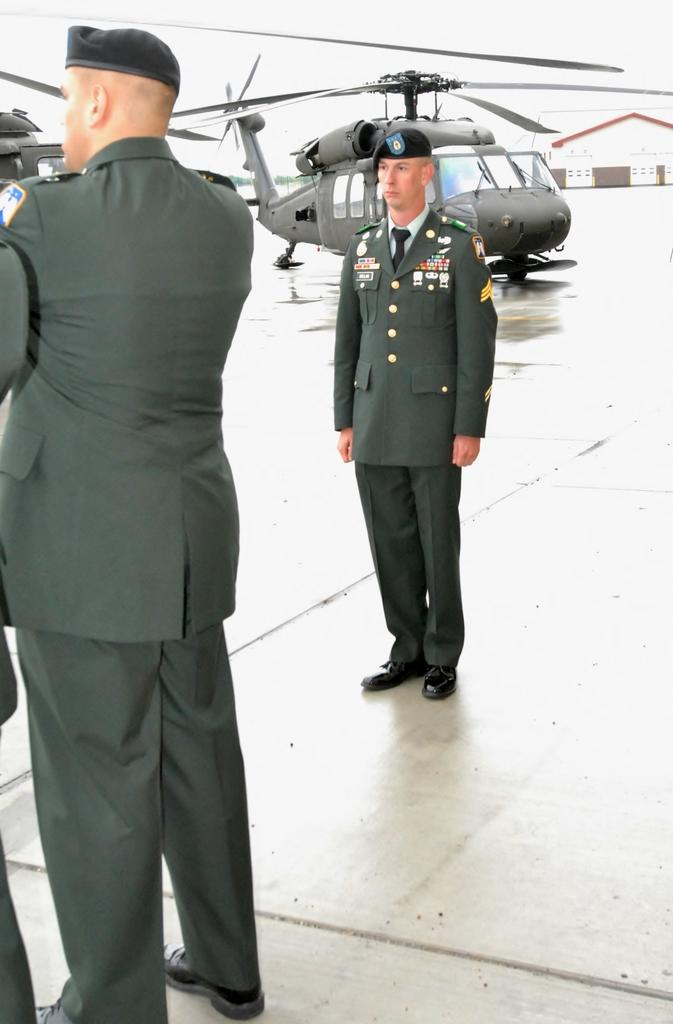What is present in the image? There are people, helicopters, and a building in the image. What can be seen in the sky in the image? The sky is visible in the image. What type of corn can be seen growing near the building in the image? There is no corn present in the image. What type of bun is being held by one of the people in the image? There is no bun visible in the image. 